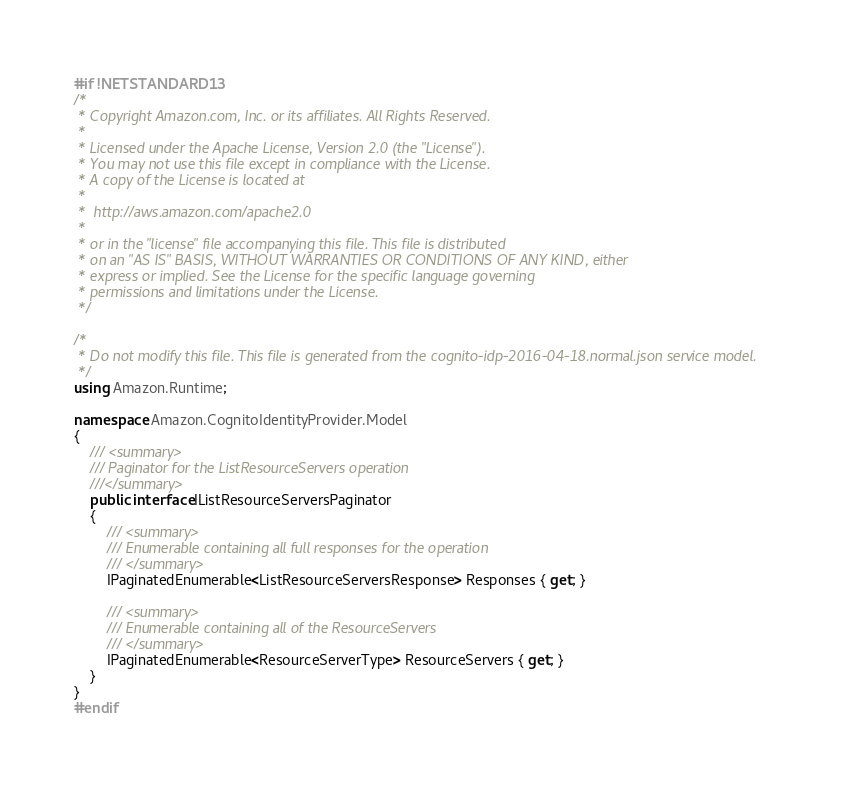Convert code to text. <code><loc_0><loc_0><loc_500><loc_500><_C#_>#if !NETSTANDARD13
/*
 * Copyright Amazon.com, Inc. or its affiliates. All Rights Reserved.
 * 
 * Licensed under the Apache License, Version 2.0 (the "License").
 * You may not use this file except in compliance with the License.
 * A copy of the License is located at
 * 
 *  http://aws.amazon.com/apache2.0
 * 
 * or in the "license" file accompanying this file. This file is distributed
 * on an "AS IS" BASIS, WITHOUT WARRANTIES OR CONDITIONS OF ANY KIND, either
 * express or implied. See the License for the specific language governing
 * permissions and limitations under the License.
 */

/*
 * Do not modify this file. This file is generated from the cognito-idp-2016-04-18.normal.json service model.
 */
using Amazon.Runtime;

namespace Amazon.CognitoIdentityProvider.Model
{
    /// <summary>
    /// Paginator for the ListResourceServers operation
    ///</summary>
    public interface IListResourceServersPaginator
    {
        /// <summary>
        /// Enumerable containing all full responses for the operation
        /// </summary>
        IPaginatedEnumerable<ListResourceServersResponse> Responses { get; }

        /// <summary>
        /// Enumerable containing all of the ResourceServers
        /// </summary>
        IPaginatedEnumerable<ResourceServerType> ResourceServers { get; }
    }
}
#endif</code> 